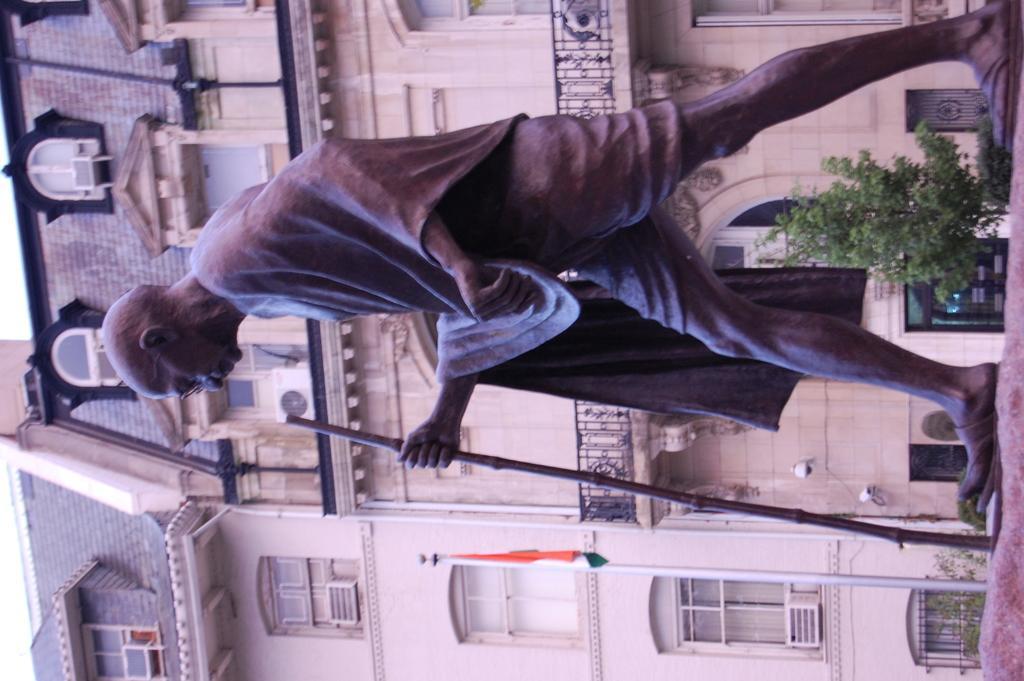In one or two sentences, can you explain what this image depicts? In this image in front there is a statue of a Mahatma Gandhi. Behind the statue there are plants. On the backside there is a building and in front of the building there is a flag. 